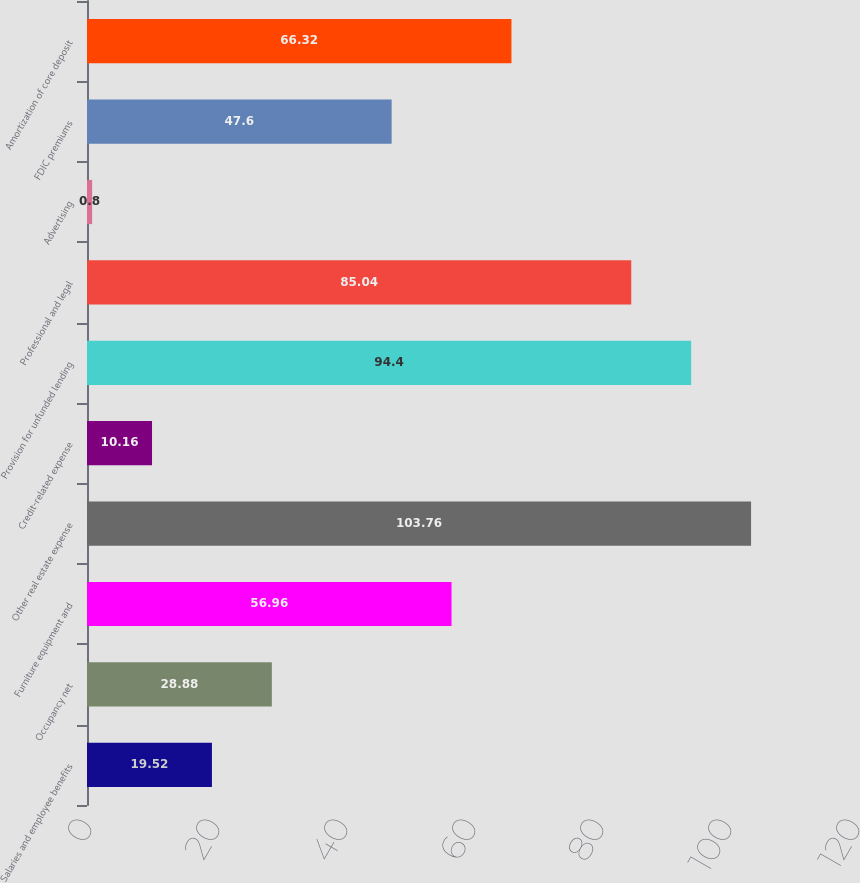Convert chart to OTSL. <chart><loc_0><loc_0><loc_500><loc_500><bar_chart><fcel>Salaries and employee benefits<fcel>Occupancy net<fcel>Furniture equipment and<fcel>Other real estate expense<fcel>Credit-related expense<fcel>Provision for unfunded lending<fcel>Professional and legal<fcel>Advertising<fcel>FDIC premiums<fcel>Amortization of core deposit<nl><fcel>19.52<fcel>28.88<fcel>56.96<fcel>103.76<fcel>10.16<fcel>94.4<fcel>85.04<fcel>0.8<fcel>47.6<fcel>66.32<nl></chart> 